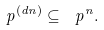Convert formula to latex. <formula><loc_0><loc_0><loc_500><loc_500>\ p ^ { ( d n ) } \subseteq \ p ^ { n } .</formula> 